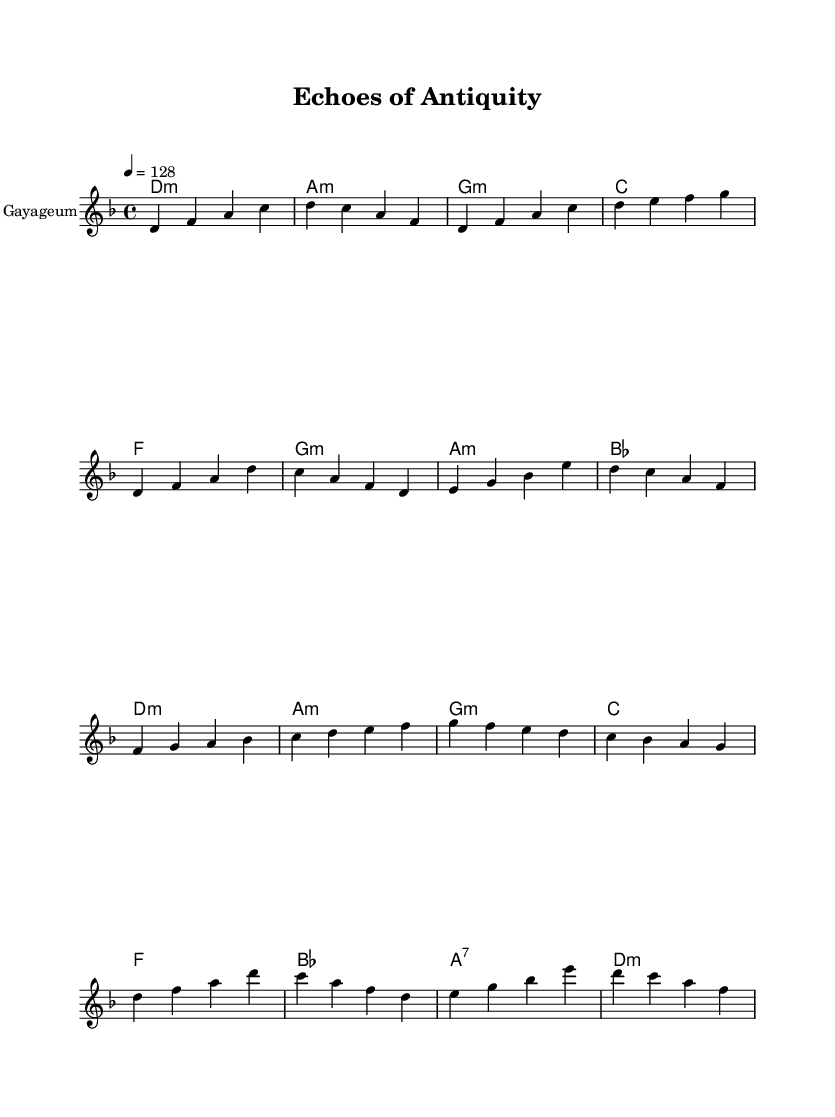What is the key signature of this music? The music is in D minor, which consists of one flat (B flat) and includes the notes that correspond to this key.
Answer: D minor What is the time signature of this music? The time signature is 4/4, indicating that there are four beats in each measure and a quarter note receives one beat.
Answer: 4/4 What is the tempo marking of this piece? The tempo marking is indicated as 4 = 128, which means there are 128 beats per minute, providing a fast-paced rhythm typical in K-Pop.
Answer: 128 How many measures are there in the chorus section? Analyzing the sheet music, the chorus is laid out over four measures (indicated by the vertical lines separating the groupings).
Answer: 4 What is the instrument represented in the sheet music? The instrument indicated on the staff is the Gayageum, a traditional Korean string instrument that aligns with K-Pop's incorporation of cultural elements.
Answer: Gayageum Which musical section includes a key change and what is the new key? The pre-chorus section starts to shift fluidly with chords but maintains the same key; there is no explicit key change in the given music. Thus, the new key is not applicable.
Answer: None What type of harmony is used in the pre-chorus? The pre-chorus utilizes minor chords primarily, which contributes to the song's emotive and dramatic feel, particularly common in K-Pop music.
Answer: Minor 